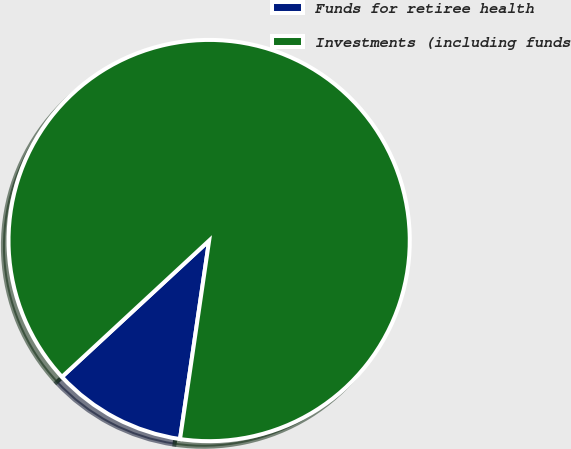<chart> <loc_0><loc_0><loc_500><loc_500><pie_chart><fcel>Funds for retiree health<fcel>Investments (including funds<nl><fcel>10.79%<fcel>89.21%<nl></chart> 